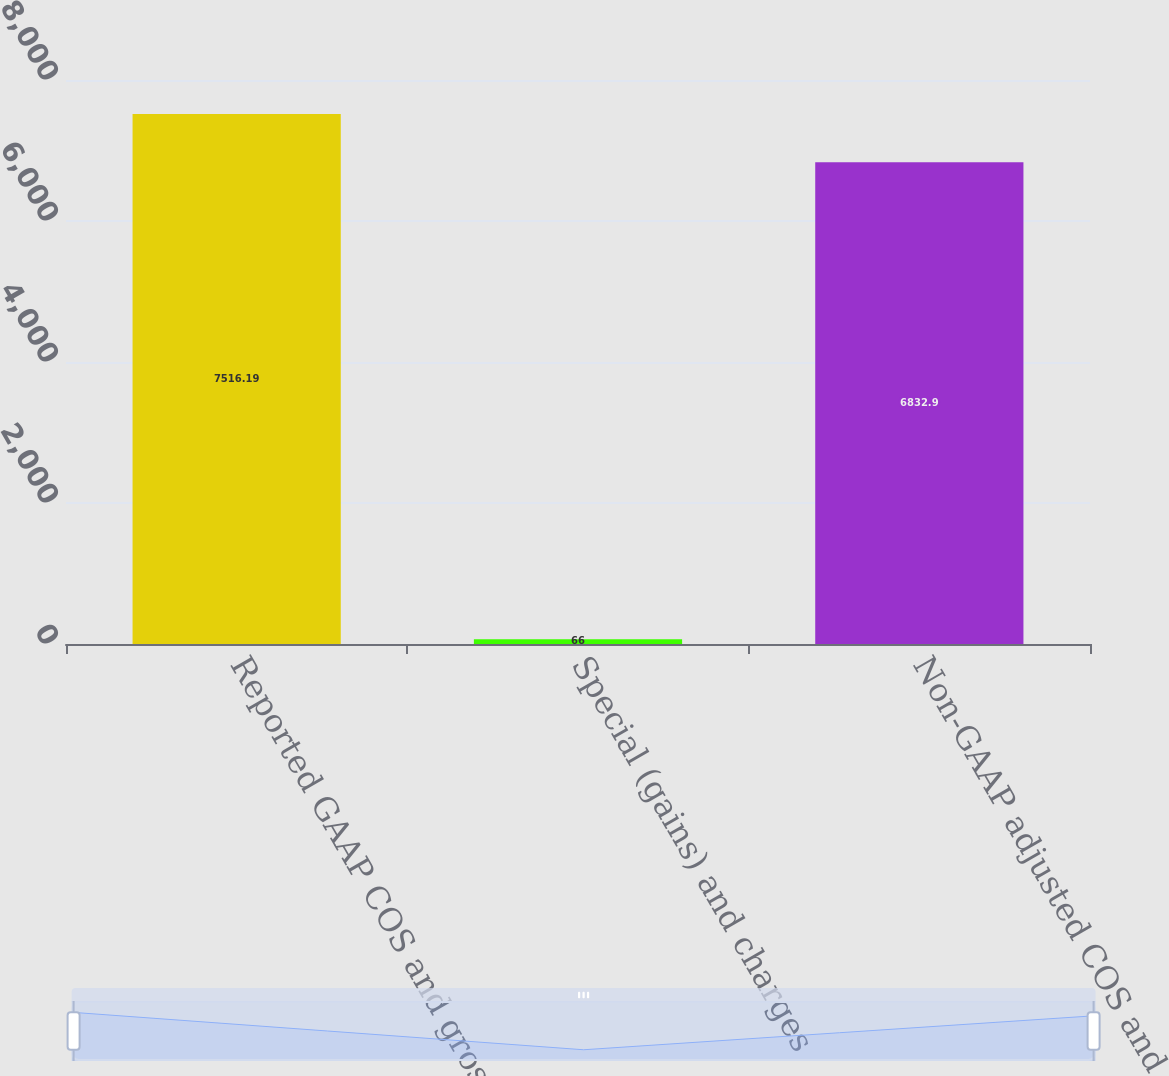Convert chart. <chart><loc_0><loc_0><loc_500><loc_500><bar_chart><fcel>Reported GAAP COS and gross<fcel>Special (gains) and charges<fcel>Non-GAAP adjusted COS and<nl><fcel>7516.19<fcel>66<fcel>6832.9<nl></chart> 